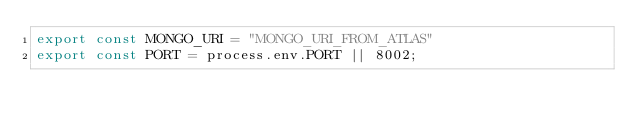<code> <loc_0><loc_0><loc_500><loc_500><_TypeScript_>export const MONGO_URI = "MONGO_URI_FROM_ATLAS"
export const PORT = process.env.PORT || 8002;</code> 